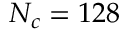<formula> <loc_0><loc_0><loc_500><loc_500>N _ { c } = 1 2 8</formula> 